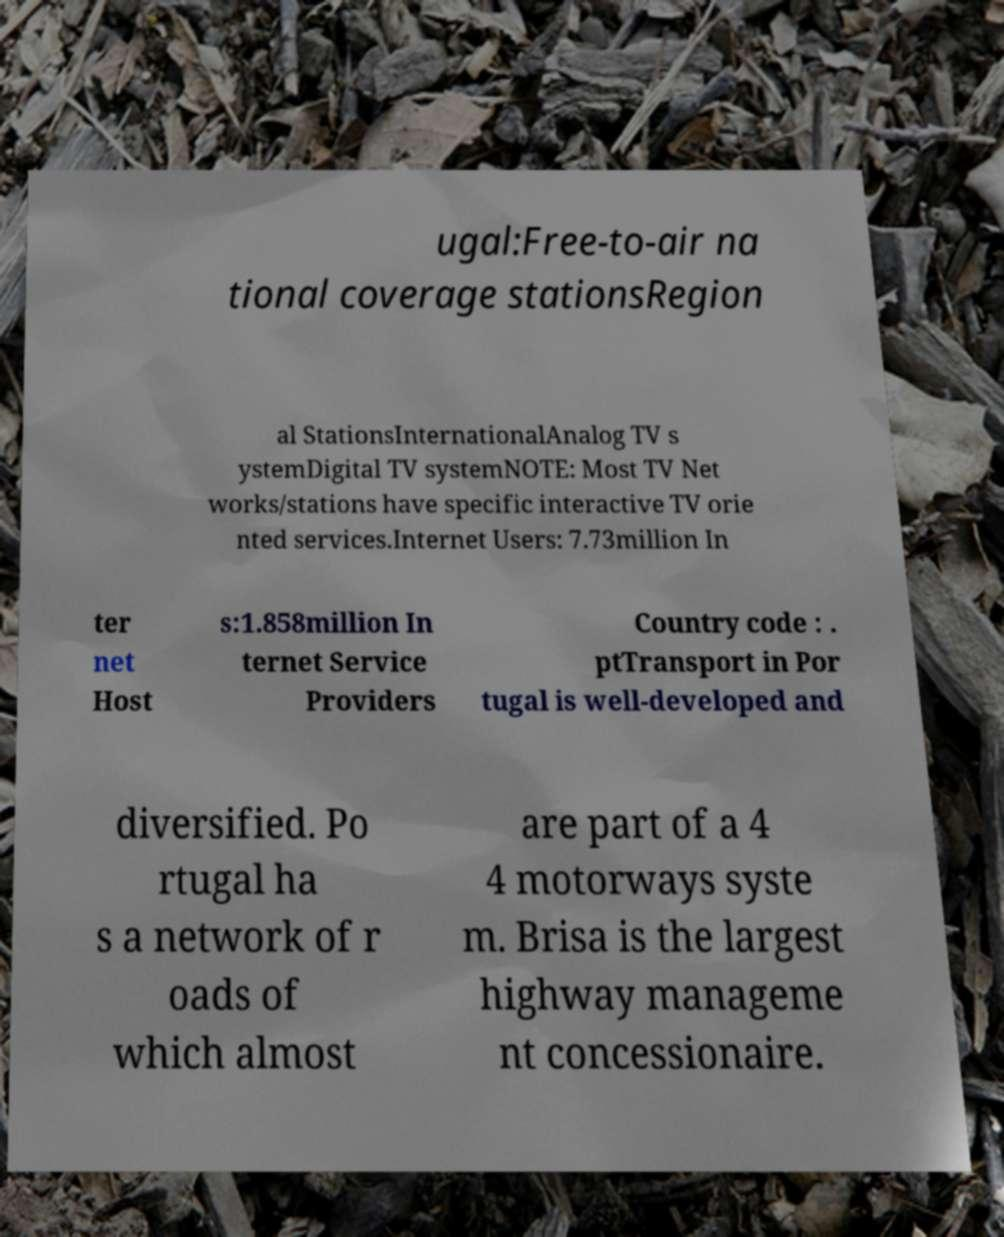Could you extract and type out the text from this image? ugal:Free-to-air na tional coverage stationsRegion al StationsInternationalAnalog TV s ystemDigital TV systemNOTE: Most TV Net works/stations have specific interactive TV orie nted services.Internet Users: 7.73million In ter net Host s:1.858million In ternet Service Providers Country code : . ptTransport in Por tugal is well-developed and diversified. Po rtugal ha s a network of r oads of which almost are part of a 4 4 motorways syste m. Brisa is the largest highway manageme nt concessionaire. 